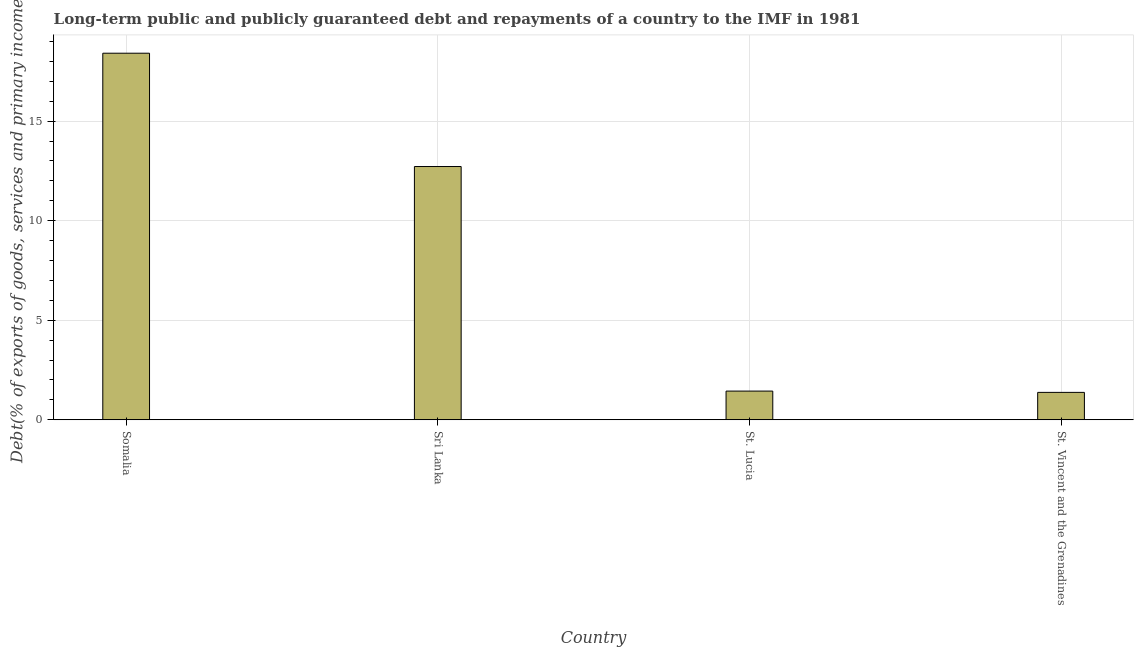Does the graph contain any zero values?
Offer a terse response. No. What is the title of the graph?
Provide a short and direct response. Long-term public and publicly guaranteed debt and repayments of a country to the IMF in 1981. What is the label or title of the Y-axis?
Your response must be concise. Debt(% of exports of goods, services and primary income). What is the debt service in Sri Lanka?
Keep it short and to the point. 12.72. Across all countries, what is the maximum debt service?
Ensure brevity in your answer.  18.41. Across all countries, what is the minimum debt service?
Provide a succinct answer. 1.38. In which country was the debt service maximum?
Your answer should be very brief. Somalia. In which country was the debt service minimum?
Make the answer very short. St. Vincent and the Grenadines. What is the sum of the debt service?
Offer a terse response. 33.95. What is the difference between the debt service in Somalia and St. Lucia?
Provide a short and direct response. 16.97. What is the average debt service per country?
Provide a succinct answer. 8.49. What is the median debt service?
Offer a terse response. 7.08. In how many countries, is the debt service greater than 6 %?
Provide a short and direct response. 2. What is the ratio of the debt service in Sri Lanka to that in St. Lucia?
Make the answer very short. 8.82. Is the difference between the debt service in St. Lucia and St. Vincent and the Grenadines greater than the difference between any two countries?
Keep it short and to the point. No. What is the difference between the highest and the second highest debt service?
Give a very brief answer. 5.69. What is the difference between the highest and the lowest debt service?
Provide a short and direct response. 17.03. Are all the bars in the graph horizontal?
Make the answer very short. No. Are the values on the major ticks of Y-axis written in scientific E-notation?
Provide a short and direct response. No. What is the Debt(% of exports of goods, services and primary income) of Somalia?
Give a very brief answer. 18.41. What is the Debt(% of exports of goods, services and primary income) in Sri Lanka?
Keep it short and to the point. 12.72. What is the Debt(% of exports of goods, services and primary income) in St. Lucia?
Offer a terse response. 1.44. What is the Debt(% of exports of goods, services and primary income) of St. Vincent and the Grenadines?
Your answer should be very brief. 1.38. What is the difference between the Debt(% of exports of goods, services and primary income) in Somalia and Sri Lanka?
Offer a terse response. 5.69. What is the difference between the Debt(% of exports of goods, services and primary income) in Somalia and St. Lucia?
Your answer should be compact. 16.97. What is the difference between the Debt(% of exports of goods, services and primary income) in Somalia and St. Vincent and the Grenadines?
Keep it short and to the point. 17.03. What is the difference between the Debt(% of exports of goods, services and primary income) in Sri Lanka and St. Lucia?
Your answer should be compact. 11.28. What is the difference between the Debt(% of exports of goods, services and primary income) in Sri Lanka and St. Vincent and the Grenadines?
Ensure brevity in your answer.  11.34. What is the difference between the Debt(% of exports of goods, services and primary income) in St. Lucia and St. Vincent and the Grenadines?
Provide a short and direct response. 0.07. What is the ratio of the Debt(% of exports of goods, services and primary income) in Somalia to that in Sri Lanka?
Your response must be concise. 1.45. What is the ratio of the Debt(% of exports of goods, services and primary income) in Somalia to that in St. Lucia?
Ensure brevity in your answer.  12.76. What is the ratio of the Debt(% of exports of goods, services and primary income) in Somalia to that in St. Vincent and the Grenadines?
Offer a very short reply. 13.37. What is the ratio of the Debt(% of exports of goods, services and primary income) in Sri Lanka to that in St. Lucia?
Your answer should be compact. 8.82. What is the ratio of the Debt(% of exports of goods, services and primary income) in Sri Lanka to that in St. Vincent and the Grenadines?
Offer a terse response. 9.23. What is the ratio of the Debt(% of exports of goods, services and primary income) in St. Lucia to that in St. Vincent and the Grenadines?
Your response must be concise. 1.05. 